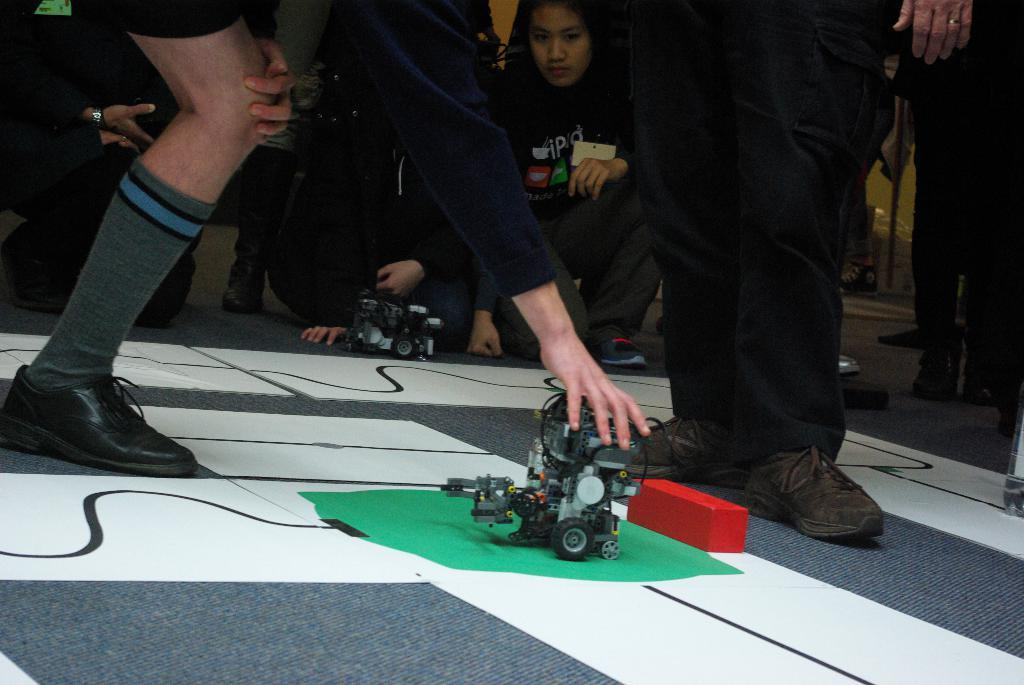What type of vehicle is in the image? There is an electronic vehicle in the image. Who is holding the electronic vehicle? A person is holding the electronic vehicle. Can you describe the position of the person at the top of the image? There is a person standing at the top of the image. What is the person at the top doing? The person at the top is looking at the electronic vehicle. Is there a veil covering the electronic vehicle in the image? No, there is no veil present in the image. What type of protest is happening in the image? There is no protest depicted in the image. 